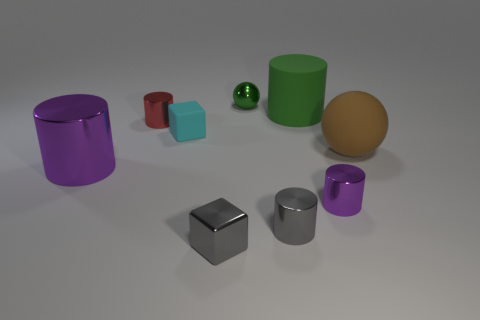Subtract all tiny red cylinders. How many cylinders are left? 4 Add 1 cyan things. How many objects exist? 10 Subtract all green spheres. How many spheres are left? 1 Subtract 1 cylinders. How many cylinders are left? 4 Subtract all cyan balls. How many purple cylinders are left? 2 Subtract all blocks. How many objects are left? 7 Subtract 0 red spheres. How many objects are left? 9 Subtract all brown cylinders. Subtract all green cubes. How many cylinders are left? 5 Subtract all brown balls. Subtract all big things. How many objects are left? 5 Add 3 small gray shiny cubes. How many small gray shiny cubes are left? 4 